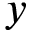<formula> <loc_0><loc_0><loc_500><loc_500>y</formula> 